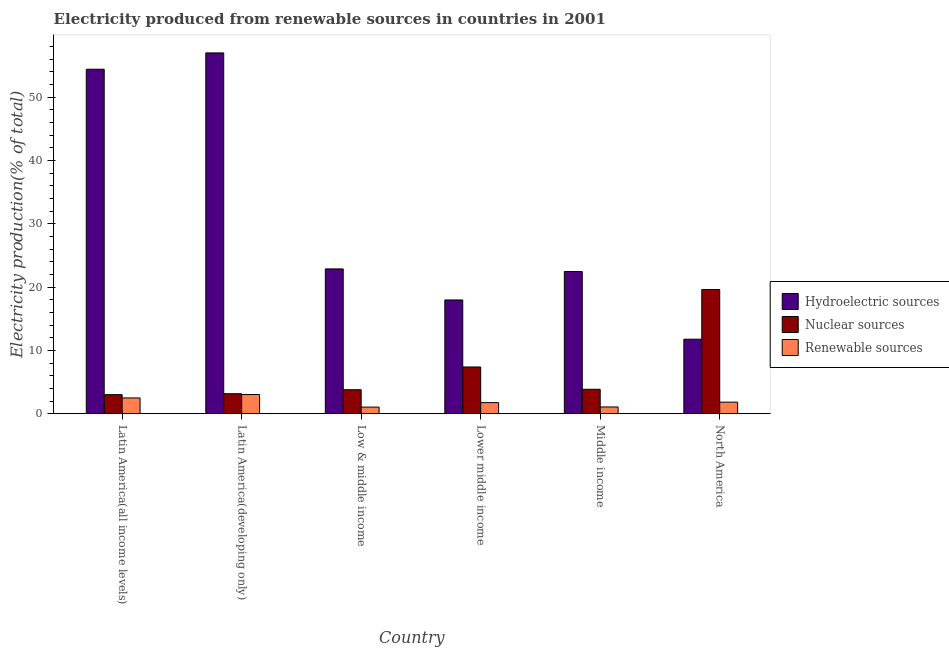How many different coloured bars are there?
Offer a terse response. 3. How many groups of bars are there?
Your answer should be very brief. 6. How many bars are there on the 1st tick from the left?
Give a very brief answer. 3. What is the label of the 2nd group of bars from the left?
Keep it short and to the point. Latin America(developing only). In how many cases, is the number of bars for a given country not equal to the number of legend labels?
Offer a terse response. 0. What is the percentage of electricity produced by renewable sources in Middle income?
Offer a very short reply. 1.07. Across all countries, what is the maximum percentage of electricity produced by nuclear sources?
Make the answer very short. 19.62. Across all countries, what is the minimum percentage of electricity produced by hydroelectric sources?
Give a very brief answer. 11.77. In which country was the percentage of electricity produced by nuclear sources maximum?
Your answer should be compact. North America. In which country was the percentage of electricity produced by hydroelectric sources minimum?
Your response must be concise. North America. What is the total percentage of electricity produced by renewable sources in the graph?
Make the answer very short. 11.23. What is the difference between the percentage of electricity produced by renewable sources in Latin America(all income levels) and that in Latin America(developing only)?
Give a very brief answer. -0.54. What is the difference between the percentage of electricity produced by nuclear sources in Latin America(developing only) and the percentage of electricity produced by renewable sources in Middle income?
Give a very brief answer. 2.09. What is the average percentage of electricity produced by hydroelectric sources per country?
Keep it short and to the point. 31.08. What is the difference between the percentage of electricity produced by nuclear sources and percentage of electricity produced by hydroelectric sources in Middle income?
Keep it short and to the point. -18.6. In how many countries, is the percentage of electricity produced by renewable sources greater than 34 %?
Your answer should be compact. 0. What is the ratio of the percentage of electricity produced by nuclear sources in Latin America(developing only) to that in Middle income?
Your answer should be very brief. 0.82. Is the percentage of electricity produced by hydroelectric sources in Middle income less than that in North America?
Keep it short and to the point. No. What is the difference between the highest and the second highest percentage of electricity produced by renewable sources?
Make the answer very short. 0.54. What is the difference between the highest and the lowest percentage of electricity produced by nuclear sources?
Keep it short and to the point. 16.61. In how many countries, is the percentage of electricity produced by hydroelectric sources greater than the average percentage of electricity produced by hydroelectric sources taken over all countries?
Offer a very short reply. 2. Is the sum of the percentage of electricity produced by renewable sources in Latin America(all income levels) and North America greater than the maximum percentage of electricity produced by hydroelectric sources across all countries?
Keep it short and to the point. No. What does the 1st bar from the left in Latin America(all income levels) represents?
Provide a succinct answer. Hydroelectric sources. What does the 1st bar from the right in Low & middle income represents?
Offer a terse response. Renewable sources. Is it the case that in every country, the sum of the percentage of electricity produced by hydroelectric sources and percentage of electricity produced by nuclear sources is greater than the percentage of electricity produced by renewable sources?
Offer a terse response. Yes. How many bars are there?
Your answer should be compact. 18. How many countries are there in the graph?
Provide a short and direct response. 6. What is the difference between two consecutive major ticks on the Y-axis?
Ensure brevity in your answer.  10. Are the values on the major ticks of Y-axis written in scientific E-notation?
Offer a terse response. No. Does the graph contain any zero values?
Your answer should be compact. No. Where does the legend appear in the graph?
Ensure brevity in your answer.  Center right. What is the title of the graph?
Your response must be concise. Electricity produced from renewable sources in countries in 2001. What is the Electricity production(% of total) of Hydroelectric sources in Latin America(all income levels)?
Keep it short and to the point. 54.4. What is the Electricity production(% of total) in Nuclear sources in Latin America(all income levels)?
Your answer should be compact. 3.01. What is the Electricity production(% of total) of Renewable sources in Latin America(all income levels)?
Keep it short and to the point. 2.5. What is the Electricity production(% of total) in Hydroelectric sources in Latin America(developing only)?
Offer a very short reply. 56.98. What is the Electricity production(% of total) in Nuclear sources in Latin America(developing only)?
Make the answer very short. 3.16. What is the Electricity production(% of total) in Renewable sources in Latin America(developing only)?
Offer a very short reply. 3.03. What is the Electricity production(% of total) in Hydroelectric sources in Low & middle income?
Your response must be concise. 22.87. What is the Electricity production(% of total) of Nuclear sources in Low & middle income?
Provide a short and direct response. 3.79. What is the Electricity production(% of total) in Renewable sources in Low & middle income?
Your answer should be very brief. 1.05. What is the Electricity production(% of total) in Hydroelectric sources in Lower middle income?
Make the answer very short. 17.97. What is the Electricity production(% of total) of Nuclear sources in Lower middle income?
Your answer should be very brief. 7.39. What is the Electricity production(% of total) in Renewable sources in Lower middle income?
Keep it short and to the point. 1.75. What is the Electricity production(% of total) in Hydroelectric sources in Middle income?
Offer a very short reply. 22.46. What is the Electricity production(% of total) of Nuclear sources in Middle income?
Give a very brief answer. 3.86. What is the Electricity production(% of total) of Renewable sources in Middle income?
Give a very brief answer. 1.07. What is the Electricity production(% of total) of Hydroelectric sources in North America?
Give a very brief answer. 11.77. What is the Electricity production(% of total) of Nuclear sources in North America?
Provide a succinct answer. 19.62. What is the Electricity production(% of total) of Renewable sources in North America?
Offer a terse response. 1.83. Across all countries, what is the maximum Electricity production(% of total) of Hydroelectric sources?
Offer a terse response. 56.98. Across all countries, what is the maximum Electricity production(% of total) of Nuclear sources?
Provide a short and direct response. 19.62. Across all countries, what is the maximum Electricity production(% of total) in Renewable sources?
Ensure brevity in your answer.  3.03. Across all countries, what is the minimum Electricity production(% of total) in Hydroelectric sources?
Your answer should be very brief. 11.77. Across all countries, what is the minimum Electricity production(% of total) in Nuclear sources?
Your response must be concise. 3.01. Across all countries, what is the minimum Electricity production(% of total) of Renewable sources?
Keep it short and to the point. 1.05. What is the total Electricity production(% of total) in Hydroelectric sources in the graph?
Provide a succinct answer. 186.45. What is the total Electricity production(% of total) in Nuclear sources in the graph?
Provide a succinct answer. 40.84. What is the total Electricity production(% of total) of Renewable sources in the graph?
Give a very brief answer. 11.23. What is the difference between the Electricity production(% of total) of Hydroelectric sources in Latin America(all income levels) and that in Latin America(developing only)?
Ensure brevity in your answer.  -2.58. What is the difference between the Electricity production(% of total) of Nuclear sources in Latin America(all income levels) and that in Latin America(developing only)?
Ensure brevity in your answer.  -0.15. What is the difference between the Electricity production(% of total) of Renewable sources in Latin America(all income levels) and that in Latin America(developing only)?
Give a very brief answer. -0.54. What is the difference between the Electricity production(% of total) in Hydroelectric sources in Latin America(all income levels) and that in Low & middle income?
Offer a very short reply. 31.53. What is the difference between the Electricity production(% of total) of Nuclear sources in Latin America(all income levels) and that in Low & middle income?
Keep it short and to the point. -0.78. What is the difference between the Electricity production(% of total) of Renewable sources in Latin America(all income levels) and that in Low & middle income?
Provide a succinct answer. 1.45. What is the difference between the Electricity production(% of total) in Hydroelectric sources in Latin America(all income levels) and that in Lower middle income?
Offer a very short reply. 36.43. What is the difference between the Electricity production(% of total) in Nuclear sources in Latin America(all income levels) and that in Lower middle income?
Offer a very short reply. -4.37. What is the difference between the Electricity production(% of total) of Renewable sources in Latin America(all income levels) and that in Lower middle income?
Your answer should be very brief. 0.74. What is the difference between the Electricity production(% of total) in Hydroelectric sources in Latin America(all income levels) and that in Middle income?
Give a very brief answer. 31.94. What is the difference between the Electricity production(% of total) of Nuclear sources in Latin America(all income levels) and that in Middle income?
Offer a very short reply. -0.85. What is the difference between the Electricity production(% of total) in Renewable sources in Latin America(all income levels) and that in Middle income?
Provide a short and direct response. 1.43. What is the difference between the Electricity production(% of total) of Hydroelectric sources in Latin America(all income levels) and that in North America?
Keep it short and to the point. 42.63. What is the difference between the Electricity production(% of total) of Nuclear sources in Latin America(all income levels) and that in North America?
Provide a short and direct response. -16.61. What is the difference between the Electricity production(% of total) in Renewable sources in Latin America(all income levels) and that in North America?
Make the answer very short. 0.66. What is the difference between the Electricity production(% of total) of Hydroelectric sources in Latin America(developing only) and that in Low & middle income?
Your response must be concise. 34.11. What is the difference between the Electricity production(% of total) of Nuclear sources in Latin America(developing only) and that in Low & middle income?
Offer a terse response. -0.63. What is the difference between the Electricity production(% of total) in Renewable sources in Latin America(developing only) and that in Low & middle income?
Provide a short and direct response. 1.98. What is the difference between the Electricity production(% of total) of Hydroelectric sources in Latin America(developing only) and that in Lower middle income?
Your answer should be compact. 39.01. What is the difference between the Electricity production(% of total) of Nuclear sources in Latin America(developing only) and that in Lower middle income?
Your answer should be very brief. -4.23. What is the difference between the Electricity production(% of total) of Renewable sources in Latin America(developing only) and that in Lower middle income?
Your response must be concise. 1.28. What is the difference between the Electricity production(% of total) in Hydroelectric sources in Latin America(developing only) and that in Middle income?
Your response must be concise. 34.52. What is the difference between the Electricity production(% of total) in Nuclear sources in Latin America(developing only) and that in Middle income?
Your answer should be very brief. -0.7. What is the difference between the Electricity production(% of total) in Renewable sources in Latin America(developing only) and that in Middle income?
Your answer should be very brief. 1.96. What is the difference between the Electricity production(% of total) in Hydroelectric sources in Latin America(developing only) and that in North America?
Your answer should be compact. 45.21. What is the difference between the Electricity production(% of total) of Nuclear sources in Latin America(developing only) and that in North America?
Give a very brief answer. -16.46. What is the difference between the Electricity production(% of total) in Renewable sources in Latin America(developing only) and that in North America?
Provide a short and direct response. 1.2. What is the difference between the Electricity production(% of total) in Hydroelectric sources in Low & middle income and that in Lower middle income?
Keep it short and to the point. 4.9. What is the difference between the Electricity production(% of total) of Nuclear sources in Low & middle income and that in Lower middle income?
Give a very brief answer. -3.59. What is the difference between the Electricity production(% of total) of Renewable sources in Low & middle income and that in Lower middle income?
Your answer should be very brief. -0.7. What is the difference between the Electricity production(% of total) of Hydroelectric sources in Low & middle income and that in Middle income?
Give a very brief answer. 0.41. What is the difference between the Electricity production(% of total) of Nuclear sources in Low & middle income and that in Middle income?
Your response must be concise. -0.07. What is the difference between the Electricity production(% of total) of Renewable sources in Low & middle income and that in Middle income?
Give a very brief answer. -0.02. What is the difference between the Electricity production(% of total) in Hydroelectric sources in Low & middle income and that in North America?
Give a very brief answer. 11.1. What is the difference between the Electricity production(% of total) in Nuclear sources in Low & middle income and that in North America?
Offer a terse response. -15.83. What is the difference between the Electricity production(% of total) of Renewable sources in Low & middle income and that in North America?
Provide a succinct answer. -0.78. What is the difference between the Electricity production(% of total) in Hydroelectric sources in Lower middle income and that in Middle income?
Your response must be concise. -4.49. What is the difference between the Electricity production(% of total) in Nuclear sources in Lower middle income and that in Middle income?
Your response must be concise. 3.52. What is the difference between the Electricity production(% of total) in Renewable sources in Lower middle income and that in Middle income?
Give a very brief answer. 0.68. What is the difference between the Electricity production(% of total) of Hydroelectric sources in Lower middle income and that in North America?
Ensure brevity in your answer.  6.2. What is the difference between the Electricity production(% of total) in Nuclear sources in Lower middle income and that in North America?
Your response must be concise. -12.24. What is the difference between the Electricity production(% of total) in Renewable sources in Lower middle income and that in North America?
Offer a terse response. -0.08. What is the difference between the Electricity production(% of total) in Hydroelectric sources in Middle income and that in North America?
Your answer should be compact. 10.69. What is the difference between the Electricity production(% of total) in Nuclear sources in Middle income and that in North America?
Make the answer very short. -15.76. What is the difference between the Electricity production(% of total) of Renewable sources in Middle income and that in North America?
Your answer should be compact. -0.76. What is the difference between the Electricity production(% of total) of Hydroelectric sources in Latin America(all income levels) and the Electricity production(% of total) of Nuclear sources in Latin America(developing only)?
Provide a short and direct response. 51.24. What is the difference between the Electricity production(% of total) in Hydroelectric sources in Latin America(all income levels) and the Electricity production(% of total) in Renewable sources in Latin America(developing only)?
Make the answer very short. 51.37. What is the difference between the Electricity production(% of total) in Nuclear sources in Latin America(all income levels) and the Electricity production(% of total) in Renewable sources in Latin America(developing only)?
Provide a short and direct response. -0.02. What is the difference between the Electricity production(% of total) of Hydroelectric sources in Latin America(all income levels) and the Electricity production(% of total) of Nuclear sources in Low & middle income?
Offer a very short reply. 50.61. What is the difference between the Electricity production(% of total) of Hydroelectric sources in Latin America(all income levels) and the Electricity production(% of total) of Renewable sources in Low & middle income?
Your answer should be compact. 53.35. What is the difference between the Electricity production(% of total) in Nuclear sources in Latin America(all income levels) and the Electricity production(% of total) in Renewable sources in Low & middle income?
Offer a terse response. 1.97. What is the difference between the Electricity production(% of total) in Hydroelectric sources in Latin America(all income levels) and the Electricity production(% of total) in Nuclear sources in Lower middle income?
Keep it short and to the point. 47.02. What is the difference between the Electricity production(% of total) of Hydroelectric sources in Latin America(all income levels) and the Electricity production(% of total) of Renewable sources in Lower middle income?
Offer a terse response. 52.65. What is the difference between the Electricity production(% of total) of Nuclear sources in Latin America(all income levels) and the Electricity production(% of total) of Renewable sources in Lower middle income?
Offer a terse response. 1.26. What is the difference between the Electricity production(% of total) in Hydroelectric sources in Latin America(all income levels) and the Electricity production(% of total) in Nuclear sources in Middle income?
Provide a short and direct response. 50.54. What is the difference between the Electricity production(% of total) in Hydroelectric sources in Latin America(all income levels) and the Electricity production(% of total) in Renewable sources in Middle income?
Keep it short and to the point. 53.33. What is the difference between the Electricity production(% of total) in Nuclear sources in Latin America(all income levels) and the Electricity production(% of total) in Renewable sources in Middle income?
Your answer should be very brief. 1.95. What is the difference between the Electricity production(% of total) of Hydroelectric sources in Latin America(all income levels) and the Electricity production(% of total) of Nuclear sources in North America?
Your response must be concise. 34.78. What is the difference between the Electricity production(% of total) of Hydroelectric sources in Latin America(all income levels) and the Electricity production(% of total) of Renewable sources in North America?
Provide a short and direct response. 52.57. What is the difference between the Electricity production(% of total) of Nuclear sources in Latin America(all income levels) and the Electricity production(% of total) of Renewable sources in North America?
Make the answer very short. 1.18. What is the difference between the Electricity production(% of total) in Hydroelectric sources in Latin America(developing only) and the Electricity production(% of total) in Nuclear sources in Low & middle income?
Your response must be concise. 53.19. What is the difference between the Electricity production(% of total) in Hydroelectric sources in Latin America(developing only) and the Electricity production(% of total) in Renewable sources in Low & middle income?
Your answer should be compact. 55.93. What is the difference between the Electricity production(% of total) in Nuclear sources in Latin America(developing only) and the Electricity production(% of total) in Renewable sources in Low & middle income?
Give a very brief answer. 2.11. What is the difference between the Electricity production(% of total) of Hydroelectric sources in Latin America(developing only) and the Electricity production(% of total) of Nuclear sources in Lower middle income?
Make the answer very short. 49.59. What is the difference between the Electricity production(% of total) in Hydroelectric sources in Latin America(developing only) and the Electricity production(% of total) in Renewable sources in Lower middle income?
Your answer should be very brief. 55.23. What is the difference between the Electricity production(% of total) in Nuclear sources in Latin America(developing only) and the Electricity production(% of total) in Renewable sources in Lower middle income?
Your response must be concise. 1.41. What is the difference between the Electricity production(% of total) in Hydroelectric sources in Latin America(developing only) and the Electricity production(% of total) in Nuclear sources in Middle income?
Provide a short and direct response. 53.12. What is the difference between the Electricity production(% of total) in Hydroelectric sources in Latin America(developing only) and the Electricity production(% of total) in Renewable sources in Middle income?
Provide a succinct answer. 55.91. What is the difference between the Electricity production(% of total) of Nuclear sources in Latin America(developing only) and the Electricity production(% of total) of Renewable sources in Middle income?
Your answer should be compact. 2.09. What is the difference between the Electricity production(% of total) of Hydroelectric sources in Latin America(developing only) and the Electricity production(% of total) of Nuclear sources in North America?
Your answer should be very brief. 37.36. What is the difference between the Electricity production(% of total) of Hydroelectric sources in Latin America(developing only) and the Electricity production(% of total) of Renewable sources in North America?
Provide a succinct answer. 55.15. What is the difference between the Electricity production(% of total) in Nuclear sources in Latin America(developing only) and the Electricity production(% of total) in Renewable sources in North America?
Offer a terse response. 1.33. What is the difference between the Electricity production(% of total) of Hydroelectric sources in Low & middle income and the Electricity production(% of total) of Nuclear sources in Lower middle income?
Your answer should be very brief. 15.48. What is the difference between the Electricity production(% of total) of Hydroelectric sources in Low & middle income and the Electricity production(% of total) of Renewable sources in Lower middle income?
Provide a short and direct response. 21.12. What is the difference between the Electricity production(% of total) of Nuclear sources in Low & middle income and the Electricity production(% of total) of Renewable sources in Lower middle income?
Offer a very short reply. 2.04. What is the difference between the Electricity production(% of total) of Hydroelectric sources in Low & middle income and the Electricity production(% of total) of Nuclear sources in Middle income?
Your response must be concise. 19.01. What is the difference between the Electricity production(% of total) in Hydroelectric sources in Low & middle income and the Electricity production(% of total) in Renewable sources in Middle income?
Offer a very short reply. 21.8. What is the difference between the Electricity production(% of total) in Nuclear sources in Low & middle income and the Electricity production(% of total) in Renewable sources in Middle income?
Your answer should be compact. 2.72. What is the difference between the Electricity production(% of total) in Hydroelectric sources in Low & middle income and the Electricity production(% of total) in Nuclear sources in North America?
Provide a succinct answer. 3.25. What is the difference between the Electricity production(% of total) of Hydroelectric sources in Low & middle income and the Electricity production(% of total) of Renewable sources in North America?
Keep it short and to the point. 21.04. What is the difference between the Electricity production(% of total) in Nuclear sources in Low & middle income and the Electricity production(% of total) in Renewable sources in North America?
Provide a short and direct response. 1.96. What is the difference between the Electricity production(% of total) in Hydroelectric sources in Lower middle income and the Electricity production(% of total) in Nuclear sources in Middle income?
Offer a very short reply. 14.11. What is the difference between the Electricity production(% of total) in Hydroelectric sources in Lower middle income and the Electricity production(% of total) in Renewable sources in Middle income?
Keep it short and to the point. 16.9. What is the difference between the Electricity production(% of total) in Nuclear sources in Lower middle income and the Electricity production(% of total) in Renewable sources in Middle income?
Your answer should be compact. 6.32. What is the difference between the Electricity production(% of total) in Hydroelectric sources in Lower middle income and the Electricity production(% of total) in Nuclear sources in North America?
Provide a succinct answer. -1.65. What is the difference between the Electricity production(% of total) in Hydroelectric sources in Lower middle income and the Electricity production(% of total) in Renewable sources in North America?
Offer a very short reply. 16.14. What is the difference between the Electricity production(% of total) of Nuclear sources in Lower middle income and the Electricity production(% of total) of Renewable sources in North America?
Your response must be concise. 5.55. What is the difference between the Electricity production(% of total) of Hydroelectric sources in Middle income and the Electricity production(% of total) of Nuclear sources in North America?
Offer a very short reply. 2.84. What is the difference between the Electricity production(% of total) of Hydroelectric sources in Middle income and the Electricity production(% of total) of Renewable sources in North America?
Keep it short and to the point. 20.63. What is the difference between the Electricity production(% of total) in Nuclear sources in Middle income and the Electricity production(% of total) in Renewable sources in North America?
Provide a succinct answer. 2.03. What is the average Electricity production(% of total) of Hydroelectric sources per country?
Your answer should be compact. 31.08. What is the average Electricity production(% of total) of Nuclear sources per country?
Keep it short and to the point. 6.81. What is the average Electricity production(% of total) in Renewable sources per country?
Offer a terse response. 1.87. What is the difference between the Electricity production(% of total) in Hydroelectric sources and Electricity production(% of total) in Nuclear sources in Latin America(all income levels)?
Your answer should be very brief. 51.39. What is the difference between the Electricity production(% of total) in Hydroelectric sources and Electricity production(% of total) in Renewable sources in Latin America(all income levels)?
Your answer should be compact. 51.91. What is the difference between the Electricity production(% of total) of Nuclear sources and Electricity production(% of total) of Renewable sources in Latin America(all income levels)?
Your response must be concise. 0.52. What is the difference between the Electricity production(% of total) of Hydroelectric sources and Electricity production(% of total) of Nuclear sources in Latin America(developing only)?
Offer a terse response. 53.82. What is the difference between the Electricity production(% of total) of Hydroelectric sources and Electricity production(% of total) of Renewable sources in Latin America(developing only)?
Provide a short and direct response. 53.95. What is the difference between the Electricity production(% of total) in Nuclear sources and Electricity production(% of total) in Renewable sources in Latin America(developing only)?
Offer a terse response. 0.13. What is the difference between the Electricity production(% of total) in Hydroelectric sources and Electricity production(% of total) in Nuclear sources in Low & middle income?
Give a very brief answer. 19.08. What is the difference between the Electricity production(% of total) in Hydroelectric sources and Electricity production(% of total) in Renewable sources in Low & middle income?
Ensure brevity in your answer.  21.82. What is the difference between the Electricity production(% of total) of Nuclear sources and Electricity production(% of total) of Renewable sources in Low & middle income?
Provide a short and direct response. 2.74. What is the difference between the Electricity production(% of total) in Hydroelectric sources and Electricity production(% of total) in Nuclear sources in Lower middle income?
Your response must be concise. 10.58. What is the difference between the Electricity production(% of total) of Hydroelectric sources and Electricity production(% of total) of Renewable sources in Lower middle income?
Your response must be concise. 16.21. What is the difference between the Electricity production(% of total) in Nuclear sources and Electricity production(% of total) in Renewable sources in Lower middle income?
Provide a short and direct response. 5.63. What is the difference between the Electricity production(% of total) of Hydroelectric sources and Electricity production(% of total) of Nuclear sources in Middle income?
Your answer should be very brief. 18.6. What is the difference between the Electricity production(% of total) in Hydroelectric sources and Electricity production(% of total) in Renewable sources in Middle income?
Keep it short and to the point. 21.39. What is the difference between the Electricity production(% of total) in Nuclear sources and Electricity production(% of total) in Renewable sources in Middle income?
Your answer should be compact. 2.79. What is the difference between the Electricity production(% of total) in Hydroelectric sources and Electricity production(% of total) in Nuclear sources in North America?
Provide a short and direct response. -7.85. What is the difference between the Electricity production(% of total) of Hydroelectric sources and Electricity production(% of total) of Renewable sources in North America?
Your answer should be compact. 9.94. What is the difference between the Electricity production(% of total) of Nuclear sources and Electricity production(% of total) of Renewable sources in North America?
Ensure brevity in your answer.  17.79. What is the ratio of the Electricity production(% of total) of Hydroelectric sources in Latin America(all income levels) to that in Latin America(developing only)?
Make the answer very short. 0.95. What is the ratio of the Electricity production(% of total) of Nuclear sources in Latin America(all income levels) to that in Latin America(developing only)?
Give a very brief answer. 0.95. What is the ratio of the Electricity production(% of total) of Renewable sources in Latin America(all income levels) to that in Latin America(developing only)?
Make the answer very short. 0.82. What is the ratio of the Electricity production(% of total) of Hydroelectric sources in Latin America(all income levels) to that in Low & middle income?
Ensure brevity in your answer.  2.38. What is the ratio of the Electricity production(% of total) of Nuclear sources in Latin America(all income levels) to that in Low & middle income?
Offer a terse response. 0.8. What is the ratio of the Electricity production(% of total) in Renewable sources in Latin America(all income levels) to that in Low & middle income?
Provide a short and direct response. 2.38. What is the ratio of the Electricity production(% of total) of Hydroelectric sources in Latin America(all income levels) to that in Lower middle income?
Offer a terse response. 3.03. What is the ratio of the Electricity production(% of total) in Nuclear sources in Latin America(all income levels) to that in Lower middle income?
Ensure brevity in your answer.  0.41. What is the ratio of the Electricity production(% of total) of Renewable sources in Latin America(all income levels) to that in Lower middle income?
Your response must be concise. 1.42. What is the ratio of the Electricity production(% of total) of Hydroelectric sources in Latin America(all income levels) to that in Middle income?
Keep it short and to the point. 2.42. What is the ratio of the Electricity production(% of total) of Nuclear sources in Latin America(all income levels) to that in Middle income?
Your answer should be compact. 0.78. What is the ratio of the Electricity production(% of total) of Renewable sources in Latin America(all income levels) to that in Middle income?
Make the answer very short. 2.33. What is the ratio of the Electricity production(% of total) of Hydroelectric sources in Latin America(all income levels) to that in North America?
Provide a short and direct response. 4.62. What is the ratio of the Electricity production(% of total) of Nuclear sources in Latin America(all income levels) to that in North America?
Make the answer very short. 0.15. What is the ratio of the Electricity production(% of total) of Renewable sources in Latin America(all income levels) to that in North America?
Make the answer very short. 1.36. What is the ratio of the Electricity production(% of total) of Hydroelectric sources in Latin America(developing only) to that in Low & middle income?
Provide a short and direct response. 2.49. What is the ratio of the Electricity production(% of total) in Nuclear sources in Latin America(developing only) to that in Low & middle income?
Ensure brevity in your answer.  0.83. What is the ratio of the Electricity production(% of total) of Renewable sources in Latin America(developing only) to that in Low & middle income?
Offer a very short reply. 2.89. What is the ratio of the Electricity production(% of total) of Hydroelectric sources in Latin America(developing only) to that in Lower middle income?
Offer a very short reply. 3.17. What is the ratio of the Electricity production(% of total) in Nuclear sources in Latin America(developing only) to that in Lower middle income?
Provide a short and direct response. 0.43. What is the ratio of the Electricity production(% of total) of Renewable sources in Latin America(developing only) to that in Lower middle income?
Provide a short and direct response. 1.73. What is the ratio of the Electricity production(% of total) of Hydroelectric sources in Latin America(developing only) to that in Middle income?
Offer a terse response. 2.54. What is the ratio of the Electricity production(% of total) in Nuclear sources in Latin America(developing only) to that in Middle income?
Keep it short and to the point. 0.82. What is the ratio of the Electricity production(% of total) of Renewable sources in Latin America(developing only) to that in Middle income?
Your answer should be very brief. 2.83. What is the ratio of the Electricity production(% of total) in Hydroelectric sources in Latin America(developing only) to that in North America?
Make the answer very short. 4.84. What is the ratio of the Electricity production(% of total) of Nuclear sources in Latin America(developing only) to that in North America?
Your answer should be compact. 0.16. What is the ratio of the Electricity production(% of total) in Renewable sources in Latin America(developing only) to that in North America?
Offer a very short reply. 1.66. What is the ratio of the Electricity production(% of total) in Hydroelectric sources in Low & middle income to that in Lower middle income?
Keep it short and to the point. 1.27. What is the ratio of the Electricity production(% of total) in Nuclear sources in Low & middle income to that in Lower middle income?
Offer a very short reply. 0.51. What is the ratio of the Electricity production(% of total) of Renewable sources in Low & middle income to that in Lower middle income?
Offer a very short reply. 0.6. What is the ratio of the Electricity production(% of total) in Hydroelectric sources in Low & middle income to that in Middle income?
Offer a very short reply. 1.02. What is the ratio of the Electricity production(% of total) of Nuclear sources in Low & middle income to that in Middle income?
Make the answer very short. 0.98. What is the ratio of the Electricity production(% of total) in Renewable sources in Low & middle income to that in Middle income?
Provide a short and direct response. 0.98. What is the ratio of the Electricity production(% of total) of Hydroelectric sources in Low & middle income to that in North America?
Give a very brief answer. 1.94. What is the ratio of the Electricity production(% of total) in Nuclear sources in Low & middle income to that in North America?
Your answer should be compact. 0.19. What is the ratio of the Electricity production(% of total) of Renewable sources in Low & middle income to that in North America?
Make the answer very short. 0.57. What is the ratio of the Electricity production(% of total) of Hydroelectric sources in Lower middle income to that in Middle income?
Ensure brevity in your answer.  0.8. What is the ratio of the Electricity production(% of total) in Nuclear sources in Lower middle income to that in Middle income?
Provide a succinct answer. 1.91. What is the ratio of the Electricity production(% of total) of Renewable sources in Lower middle income to that in Middle income?
Provide a succinct answer. 1.64. What is the ratio of the Electricity production(% of total) in Hydroelectric sources in Lower middle income to that in North America?
Your response must be concise. 1.53. What is the ratio of the Electricity production(% of total) of Nuclear sources in Lower middle income to that in North America?
Make the answer very short. 0.38. What is the ratio of the Electricity production(% of total) in Renewable sources in Lower middle income to that in North America?
Provide a short and direct response. 0.96. What is the ratio of the Electricity production(% of total) in Hydroelectric sources in Middle income to that in North America?
Ensure brevity in your answer.  1.91. What is the ratio of the Electricity production(% of total) of Nuclear sources in Middle income to that in North America?
Keep it short and to the point. 0.2. What is the ratio of the Electricity production(% of total) in Renewable sources in Middle income to that in North America?
Offer a very short reply. 0.58. What is the difference between the highest and the second highest Electricity production(% of total) of Hydroelectric sources?
Keep it short and to the point. 2.58. What is the difference between the highest and the second highest Electricity production(% of total) of Nuclear sources?
Give a very brief answer. 12.24. What is the difference between the highest and the second highest Electricity production(% of total) of Renewable sources?
Provide a short and direct response. 0.54. What is the difference between the highest and the lowest Electricity production(% of total) in Hydroelectric sources?
Your answer should be compact. 45.21. What is the difference between the highest and the lowest Electricity production(% of total) of Nuclear sources?
Your answer should be very brief. 16.61. What is the difference between the highest and the lowest Electricity production(% of total) of Renewable sources?
Make the answer very short. 1.98. 